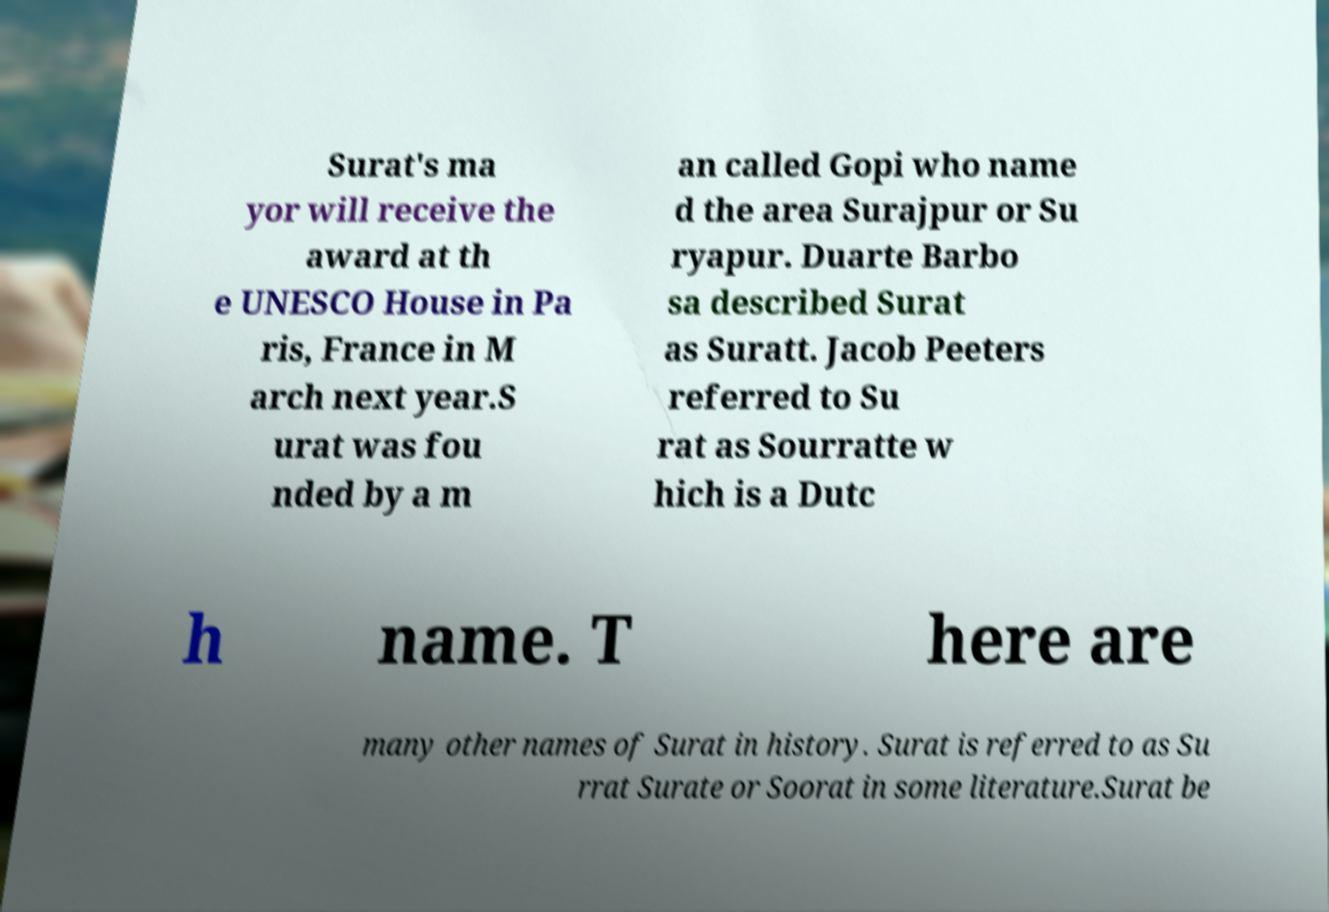There's text embedded in this image that I need extracted. Can you transcribe it verbatim? Surat's ma yor will receive the award at th e UNESCO House in Pa ris, France in M arch next year.S urat was fou nded by a m an called Gopi who name d the area Surajpur or Su ryapur. Duarte Barbo sa described Surat as Suratt. Jacob Peeters referred to Su rat as Sourratte w hich is a Dutc h name. T here are many other names of Surat in history. Surat is referred to as Su rrat Surate or Soorat in some literature.Surat be 